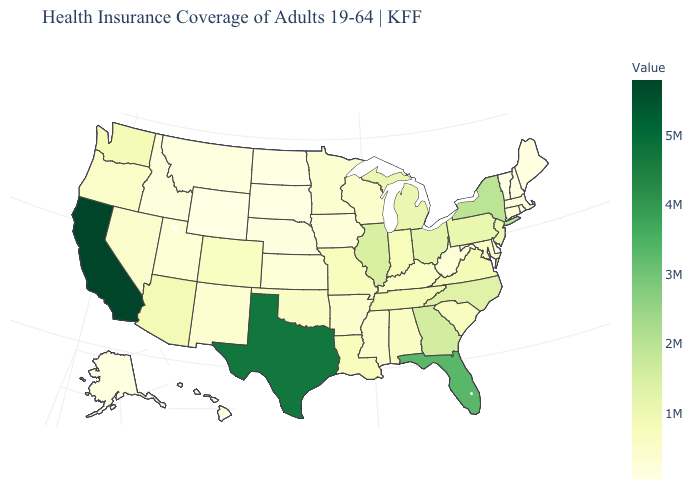Among the states that border New Hampshire , does Vermont have the lowest value?
Answer briefly. Yes. Which states hav the highest value in the West?
Quick response, please. California. Does Maine have a higher value than Illinois?
Quick response, please. No. Which states have the lowest value in the Northeast?
Give a very brief answer. Vermont. Which states have the lowest value in the USA?
Give a very brief answer. Vermont. Does Vermont have the lowest value in the USA?
Write a very short answer. Yes. 